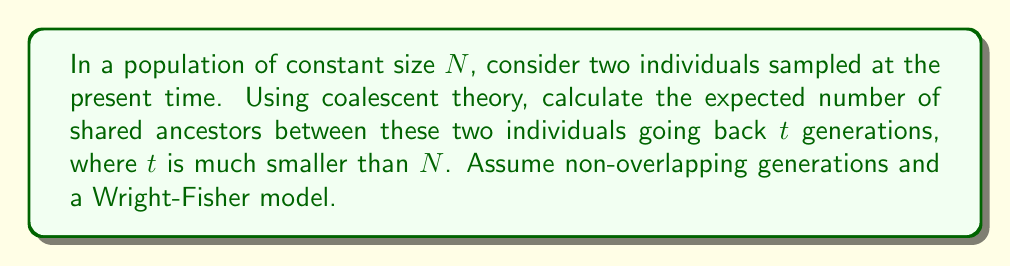Could you help me with this problem? To solve this problem, we'll use coalescent theory and follow these steps:

1) In coalescent theory, the probability of coalescence (finding a common ancestor) in a single generation is $\frac{1}{2N}$ for a pair of lineages.

2) The probability of not coalescing in a single generation is therefore $1 - \frac{1}{2N}$.

3) The probability of not coalescing for $t$ generations is $(1 - \frac{1}{2N})^t$.

4) Thus, the probability of coalescing within $t$ generations is $1 - (1 - \frac{1}{2N})^t$.

5) Given that $t$ is much smaller than $N$, we can use the approximation $(1-x)^n \approx 1-nx$ for small $x$. Here, $x = \frac{1}{2N}$ and $n = t$.

6) Applying this approximation:
   $1 - (1 - \frac{1}{2N})^t \approx 1 - (1 - \frac{t}{2N}) = \frac{t}{2N}$

7) The expected number of shared ancestors is 1 if they coalesce within $t$ generations, and 0 otherwise. Therefore, the expected number of shared ancestors is equal to the probability of coalescence within $t$ generations.

8) Thus, the expected number of shared ancestors is approximately $\frac{t}{2N}$.

This result aligns with the biological intuition that the number of shared ancestors increases with the number of generations considered ($t$) and decreases with larger population sizes ($N$).
Answer: $\frac{t}{2N}$ 